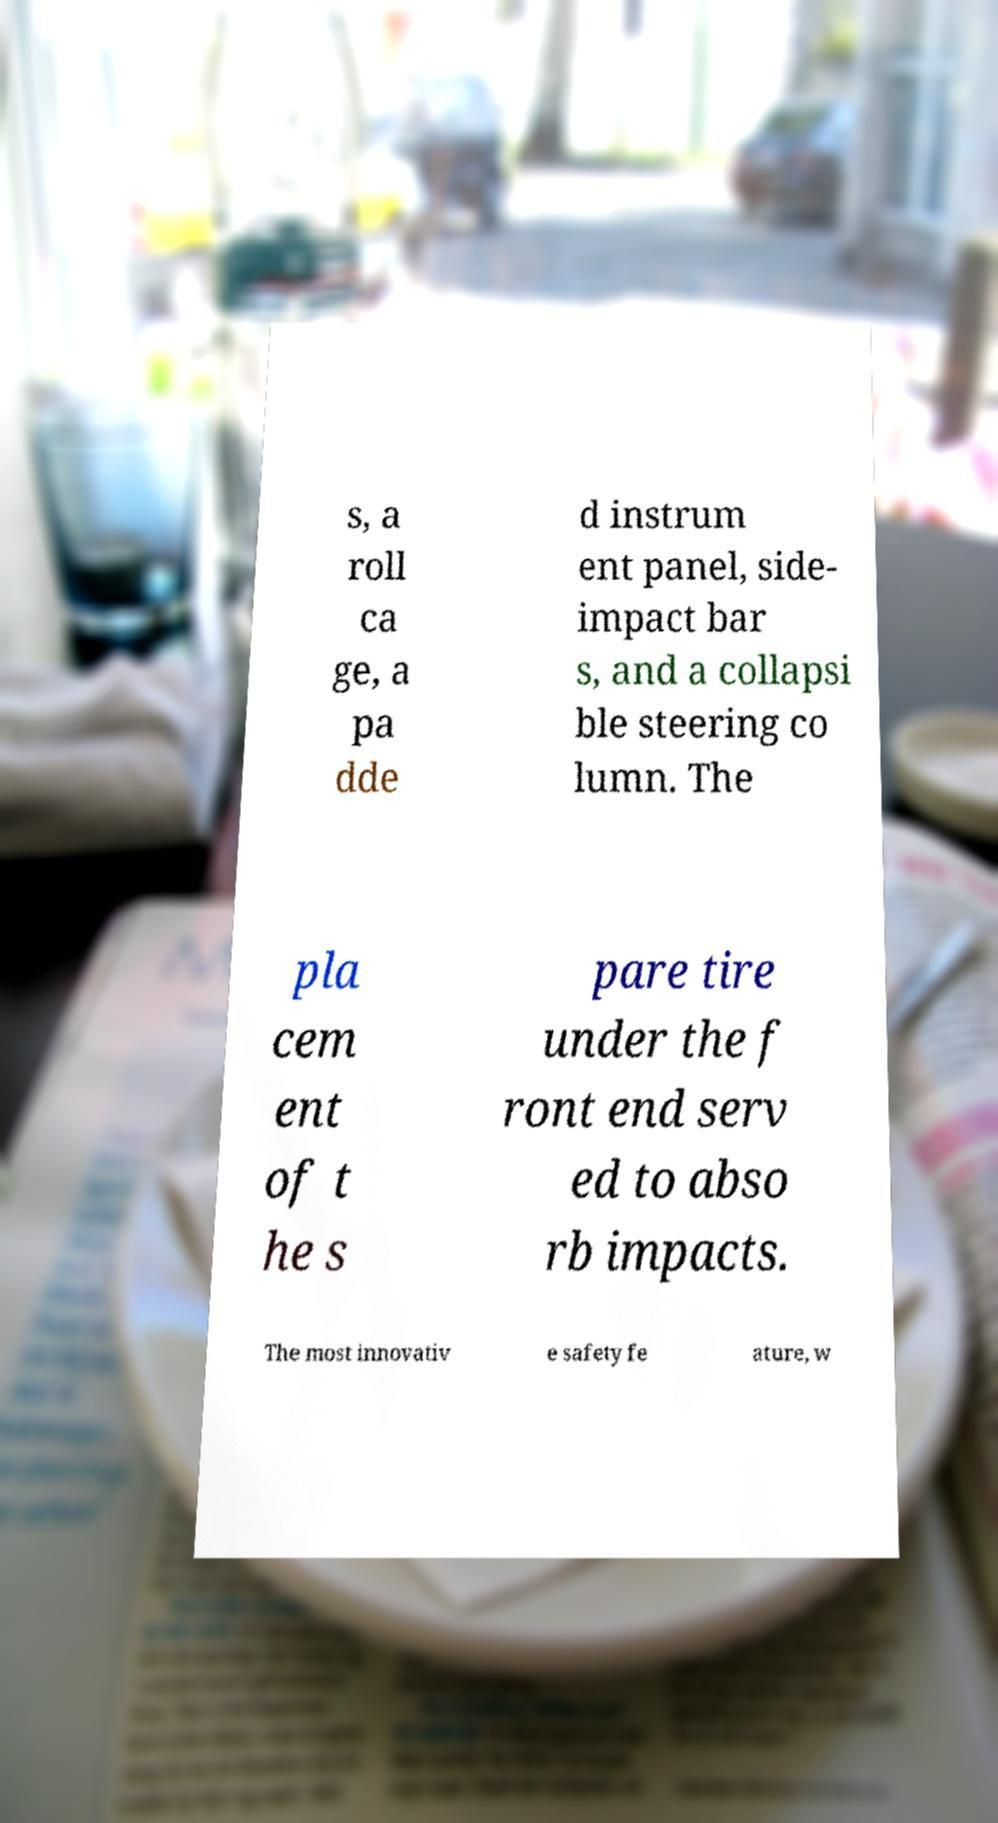There's text embedded in this image that I need extracted. Can you transcribe it verbatim? s, a roll ca ge, a pa dde d instrum ent panel, side- impact bar s, and a collapsi ble steering co lumn. The pla cem ent of t he s pare tire under the f ront end serv ed to abso rb impacts. The most innovativ e safety fe ature, w 